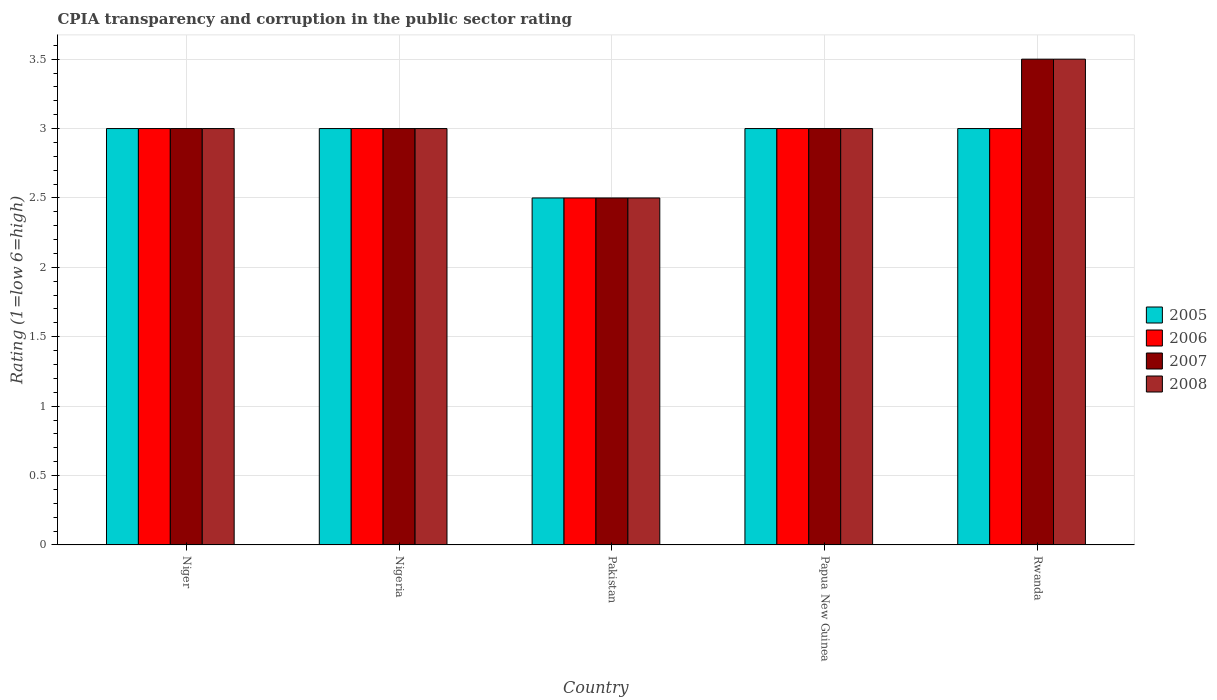What is the label of the 3rd group of bars from the left?
Provide a succinct answer. Pakistan. What is the CPIA rating in 2007 in Rwanda?
Provide a succinct answer. 3.5. Across all countries, what is the maximum CPIA rating in 2007?
Make the answer very short. 3.5. Across all countries, what is the minimum CPIA rating in 2005?
Offer a terse response. 2.5. In which country was the CPIA rating in 2008 maximum?
Offer a terse response. Rwanda. What is the difference between the CPIA rating in 2006 in Papua New Guinea and that in Rwanda?
Ensure brevity in your answer.  0. Is the difference between the CPIA rating in 2005 in Nigeria and Pakistan greater than the difference between the CPIA rating in 2007 in Nigeria and Pakistan?
Offer a terse response. No. What is the difference between the highest and the lowest CPIA rating in 2007?
Offer a terse response. 1. In how many countries, is the CPIA rating in 2007 greater than the average CPIA rating in 2007 taken over all countries?
Keep it short and to the point. 1. Is it the case that in every country, the sum of the CPIA rating in 2007 and CPIA rating in 2008 is greater than the sum of CPIA rating in 2006 and CPIA rating in 2005?
Provide a succinct answer. No. What does the 1st bar from the right in Papua New Guinea represents?
Your answer should be very brief. 2008. Is it the case that in every country, the sum of the CPIA rating in 2007 and CPIA rating in 2006 is greater than the CPIA rating in 2008?
Your answer should be compact. Yes. What is the difference between two consecutive major ticks on the Y-axis?
Make the answer very short. 0.5. Are the values on the major ticks of Y-axis written in scientific E-notation?
Provide a short and direct response. No. Where does the legend appear in the graph?
Provide a succinct answer. Center right. How are the legend labels stacked?
Your answer should be very brief. Vertical. What is the title of the graph?
Offer a very short reply. CPIA transparency and corruption in the public sector rating. Does "2012" appear as one of the legend labels in the graph?
Give a very brief answer. No. What is the label or title of the X-axis?
Your answer should be very brief. Country. What is the label or title of the Y-axis?
Provide a short and direct response. Rating (1=low 6=high). What is the Rating (1=low 6=high) in 2005 in Nigeria?
Offer a very short reply. 3. What is the Rating (1=low 6=high) in 2006 in Nigeria?
Provide a succinct answer. 3. What is the Rating (1=low 6=high) of 2007 in Nigeria?
Give a very brief answer. 3. What is the Rating (1=low 6=high) of 2005 in Pakistan?
Offer a terse response. 2.5. What is the Rating (1=low 6=high) of 2006 in Pakistan?
Your answer should be compact. 2.5. What is the Rating (1=low 6=high) in 2005 in Papua New Guinea?
Keep it short and to the point. 3. What is the Rating (1=low 6=high) in 2006 in Papua New Guinea?
Provide a succinct answer. 3. What is the Rating (1=low 6=high) in 2007 in Papua New Guinea?
Your response must be concise. 3. What is the Rating (1=low 6=high) in 2008 in Papua New Guinea?
Keep it short and to the point. 3. What is the Rating (1=low 6=high) in 2005 in Rwanda?
Make the answer very short. 3. What is the Rating (1=low 6=high) of 2007 in Rwanda?
Your answer should be compact. 3.5. What is the Rating (1=low 6=high) in 2008 in Rwanda?
Make the answer very short. 3.5. Across all countries, what is the maximum Rating (1=low 6=high) in 2005?
Offer a terse response. 3. Across all countries, what is the maximum Rating (1=low 6=high) in 2006?
Give a very brief answer. 3. Across all countries, what is the maximum Rating (1=low 6=high) of 2007?
Keep it short and to the point. 3.5. Across all countries, what is the minimum Rating (1=low 6=high) of 2005?
Your response must be concise. 2.5. What is the total Rating (1=low 6=high) in 2008 in the graph?
Offer a terse response. 15. What is the difference between the Rating (1=low 6=high) in 2008 in Niger and that in Nigeria?
Your answer should be very brief. 0. What is the difference between the Rating (1=low 6=high) in 2005 in Niger and that in Papua New Guinea?
Your answer should be compact. 0. What is the difference between the Rating (1=low 6=high) in 2007 in Niger and that in Papua New Guinea?
Keep it short and to the point. 0. What is the difference between the Rating (1=low 6=high) of 2008 in Niger and that in Papua New Guinea?
Your response must be concise. 0. What is the difference between the Rating (1=low 6=high) of 2005 in Niger and that in Rwanda?
Offer a terse response. 0. What is the difference between the Rating (1=low 6=high) of 2007 in Niger and that in Rwanda?
Keep it short and to the point. -0.5. What is the difference between the Rating (1=low 6=high) of 2008 in Niger and that in Rwanda?
Make the answer very short. -0.5. What is the difference between the Rating (1=low 6=high) in 2007 in Nigeria and that in Pakistan?
Offer a very short reply. 0.5. What is the difference between the Rating (1=low 6=high) in 2008 in Nigeria and that in Pakistan?
Your response must be concise. 0.5. What is the difference between the Rating (1=low 6=high) in 2007 in Nigeria and that in Papua New Guinea?
Give a very brief answer. 0. What is the difference between the Rating (1=low 6=high) in 2008 in Nigeria and that in Papua New Guinea?
Provide a succinct answer. 0. What is the difference between the Rating (1=low 6=high) in 2005 in Pakistan and that in Papua New Guinea?
Provide a short and direct response. -0.5. What is the difference between the Rating (1=low 6=high) in 2007 in Pakistan and that in Papua New Guinea?
Give a very brief answer. -0.5. What is the difference between the Rating (1=low 6=high) of 2008 in Pakistan and that in Papua New Guinea?
Offer a very short reply. -0.5. What is the difference between the Rating (1=low 6=high) of 2005 in Pakistan and that in Rwanda?
Give a very brief answer. -0.5. What is the difference between the Rating (1=low 6=high) in 2007 in Papua New Guinea and that in Rwanda?
Keep it short and to the point. -0.5. What is the difference between the Rating (1=low 6=high) of 2008 in Papua New Guinea and that in Rwanda?
Offer a terse response. -0.5. What is the difference between the Rating (1=low 6=high) of 2005 in Niger and the Rating (1=low 6=high) of 2008 in Nigeria?
Ensure brevity in your answer.  0. What is the difference between the Rating (1=low 6=high) of 2006 in Niger and the Rating (1=low 6=high) of 2007 in Nigeria?
Provide a succinct answer. 0. What is the difference between the Rating (1=low 6=high) of 2005 in Niger and the Rating (1=low 6=high) of 2006 in Pakistan?
Provide a short and direct response. 0.5. What is the difference between the Rating (1=low 6=high) in 2006 in Niger and the Rating (1=low 6=high) in 2007 in Pakistan?
Make the answer very short. 0.5. What is the difference between the Rating (1=low 6=high) in 2007 in Niger and the Rating (1=low 6=high) in 2008 in Pakistan?
Provide a short and direct response. 0.5. What is the difference between the Rating (1=low 6=high) in 2006 in Niger and the Rating (1=low 6=high) in 2008 in Papua New Guinea?
Offer a very short reply. 0. What is the difference between the Rating (1=low 6=high) in 2005 in Niger and the Rating (1=low 6=high) in 2006 in Rwanda?
Provide a succinct answer. 0. What is the difference between the Rating (1=low 6=high) in 2005 in Niger and the Rating (1=low 6=high) in 2007 in Rwanda?
Make the answer very short. -0.5. What is the difference between the Rating (1=low 6=high) in 2005 in Niger and the Rating (1=low 6=high) in 2008 in Rwanda?
Provide a short and direct response. -0.5. What is the difference between the Rating (1=low 6=high) in 2006 in Niger and the Rating (1=low 6=high) in 2008 in Rwanda?
Give a very brief answer. -0.5. What is the difference between the Rating (1=low 6=high) in 2007 in Niger and the Rating (1=low 6=high) in 2008 in Rwanda?
Ensure brevity in your answer.  -0.5. What is the difference between the Rating (1=low 6=high) in 2005 in Nigeria and the Rating (1=low 6=high) in 2006 in Pakistan?
Offer a very short reply. 0.5. What is the difference between the Rating (1=low 6=high) of 2005 in Nigeria and the Rating (1=low 6=high) of 2007 in Pakistan?
Make the answer very short. 0.5. What is the difference between the Rating (1=low 6=high) in 2006 in Nigeria and the Rating (1=low 6=high) in 2007 in Pakistan?
Offer a very short reply. 0.5. What is the difference between the Rating (1=low 6=high) in 2007 in Nigeria and the Rating (1=low 6=high) in 2008 in Pakistan?
Your response must be concise. 0.5. What is the difference between the Rating (1=low 6=high) in 2005 in Nigeria and the Rating (1=low 6=high) in 2006 in Papua New Guinea?
Your answer should be very brief. 0. What is the difference between the Rating (1=low 6=high) of 2006 in Nigeria and the Rating (1=low 6=high) of 2008 in Papua New Guinea?
Offer a very short reply. 0. What is the difference between the Rating (1=low 6=high) in 2007 in Nigeria and the Rating (1=low 6=high) in 2008 in Papua New Guinea?
Provide a succinct answer. 0. What is the difference between the Rating (1=low 6=high) of 2005 in Nigeria and the Rating (1=low 6=high) of 2006 in Rwanda?
Keep it short and to the point. 0. What is the difference between the Rating (1=low 6=high) in 2005 in Nigeria and the Rating (1=low 6=high) in 2008 in Rwanda?
Your answer should be very brief. -0.5. What is the difference between the Rating (1=low 6=high) in 2007 in Pakistan and the Rating (1=low 6=high) in 2008 in Papua New Guinea?
Provide a succinct answer. -0.5. What is the difference between the Rating (1=low 6=high) in 2005 in Pakistan and the Rating (1=low 6=high) in 2006 in Rwanda?
Your answer should be very brief. -0.5. What is the difference between the Rating (1=low 6=high) in 2005 in Pakistan and the Rating (1=low 6=high) in 2007 in Rwanda?
Offer a very short reply. -1. What is the difference between the Rating (1=low 6=high) of 2005 in Pakistan and the Rating (1=low 6=high) of 2008 in Rwanda?
Your answer should be very brief. -1. What is the difference between the Rating (1=low 6=high) in 2006 in Pakistan and the Rating (1=low 6=high) in 2007 in Rwanda?
Offer a very short reply. -1. What is the difference between the Rating (1=low 6=high) of 2006 in Pakistan and the Rating (1=low 6=high) of 2008 in Rwanda?
Your answer should be compact. -1. What is the difference between the Rating (1=low 6=high) in 2007 in Pakistan and the Rating (1=low 6=high) in 2008 in Rwanda?
Provide a succinct answer. -1. What is the difference between the Rating (1=low 6=high) in 2006 in Papua New Guinea and the Rating (1=low 6=high) in 2008 in Rwanda?
Give a very brief answer. -0.5. What is the difference between the Rating (1=low 6=high) in 2007 in Papua New Guinea and the Rating (1=low 6=high) in 2008 in Rwanda?
Give a very brief answer. -0.5. What is the average Rating (1=low 6=high) of 2005 per country?
Your answer should be very brief. 2.9. What is the average Rating (1=low 6=high) in 2006 per country?
Your response must be concise. 2.9. What is the average Rating (1=low 6=high) in 2007 per country?
Give a very brief answer. 3. What is the average Rating (1=low 6=high) in 2008 per country?
Your answer should be very brief. 3. What is the difference between the Rating (1=low 6=high) of 2005 and Rating (1=low 6=high) of 2007 in Niger?
Make the answer very short. 0. What is the difference between the Rating (1=low 6=high) of 2006 and Rating (1=low 6=high) of 2008 in Niger?
Keep it short and to the point. 0. What is the difference between the Rating (1=low 6=high) of 2005 and Rating (1=low 6=high) of 2008 in Nigeria?
Make the answer very short. 0. What is the difference between the Rating (1=low 6=high) in 2006 and Rating (1=low 6=high) in 2007 in Nigeria?
Offer a very short reply. 0. What is the difference between the Rating (1=low 6=high) of 2007 and Rating (1=low 6=high) of 2008 in Nigeria?
Offer a terse response. 0. What is the difference between the Rating (1=low 6=high) of 2005 and Rating (1=low 6=high) of 2006 in Pakistan?
Offer a very short reply. 0. What is the difference between the Rating (1=low 6=high) of 2005 and Rating (1=low 6=high) of 2007 in Pakistan?
Make the answer very short. 0. What is the difference between the Rating (1=low 6=high) of 2005 and Rating (1=low 6=high) of 2008 in Pakistan?
Offer a very short reply. 0. What is the difference between the Rating (1=low 6=high) in 2005 and Rating (1=low 6=high) in 2008 in Papua New Guinea?
Provide a succinct answer. 0. What is the difference between the Rating (1=low 6=high) of 2006 and Rating (1=low 6=high) of 2007 in Papua New Guinea?
Make the answer very short. 0. What is the difference between the Rating (1=low 6=high) in 2006 and Rating (1=low 6=high) in 2008 in Papua New Guinea?
Give a very brief answer. 0. What is the difference between the Rating (1=low 6=high) in 2007 and Rating (1=low 6=high) in 2008 in Papua New Guinea?
Ensure brevity in your answer.  0. What is the difference between the Rating (1=low 6=high) in 2005 and Rating (1=low 6=high) in 2007 in Rwanda?
Provide a succinct answer. -0.5. What is the difference between the Rating (1=low 6=high) in 2006 and Rating (1=low 6=high) in 2007 in Rwanda?
Ensure brevity in your answer.  -0.5. What is the ratio of the Rating (1=low 6=high) in 2005 in Niger to that in Nigeria?
Offer a very short reply. 1. What is the ratio of the Rating (1=low 6=high) of 2007 in Niger to that in Pakistan?
Offer a terse response. 1.2. What is the ratio of the Rating (1=low 6=high) of 2007 in Niger to that in Papua New Guinea?
Your response must be concise. 1. What is the ratio of the Rating (1=low 6=high) in 2008 in Niger to that in Papua New Guinea?
Give a very brief answer. 1. What is the ratio of the Rating (1=low 6=high) in 2006 in Niger to that in Rwanda?
Keep it short and to the point. 1. What is the ratio of the Rating (1=low 6=high) in 2007 in Niger to that in Rwanda?
Your answer should be compact. 0.86. What is the ratio of the Rating (1=low 6=high) in 2005 in Nigeria to that in Pakistan?
Your answer should be compact. 1.2. What is the ratio of the Rating (1=low 6=high) in 2008 in Nigeria to that in Pakistan?
Offer a very short reply. 1.2. What is the ratio of the Rating (1=low 6=high) in 2005 in Nigeria to that in Papua New Guinea?
Provide a succinct answer. 1. What is the ratio of the Rating (1=low 6=high) of 2008 in Nigeria to that in Papua New Guinea?
Ensure brevity in your answer.  1. What is the ratio of the Rating (1=low 6=high) in 2006 in Nigeria to that in Rwanda?
Provide a short and direct response. 1. What is the ratio of the Rating (1=low 6=high) of 2008 in Nigeria to that in Rwanda?
Offer a terse response. 0.86. What is the ratio of the Rating (1=low 6=high) of 2005 in Pakistan to that in Papua New Guinea?
Offer a very short reply. 0.83. What is the ratio of the Rating (1=low 6=high) of 2006 in Pakistan to that in Papua New Guinea?
Your answer should be compact. 0.83. What is the ratio of the Rating (1=low 6=high) of 2008 in Pakistan to that in Papua New Guinea?
Your answer should be compact. 0.83. What is the ratio of the Rating (1=low 6=high) in 2006 in Pakistan to that in Rwanda?
Your answer should be very brief. 0.83. What is the ratio of the Rating (1=low 6=high) of 2007 in Papua New Guinea to that in Rwanda?
Make the answer very short. 0.86. What is the ratio of the Rating (1=low 6=high) in 2008 in Papua New Guinea to that in Rwanda?
Make the answer very short. 0.86. What is the difference between the highest and the second highest Rating (1=low 6=high) of 2006?
Offer a very short reply. 0. What is the difference between the highest and the second highest Rating (1=low 6=high) of 2007?
Make the answer very short. 0.5. What is the difference between the highest and the lowest Rating (1=low 6=high) of 2006?
Ensure brevity in your answer.  0.5. What is the difference between the highest and the lowest Rating (1=low 6=high) of 2007?
Make the answer very short. 1. 